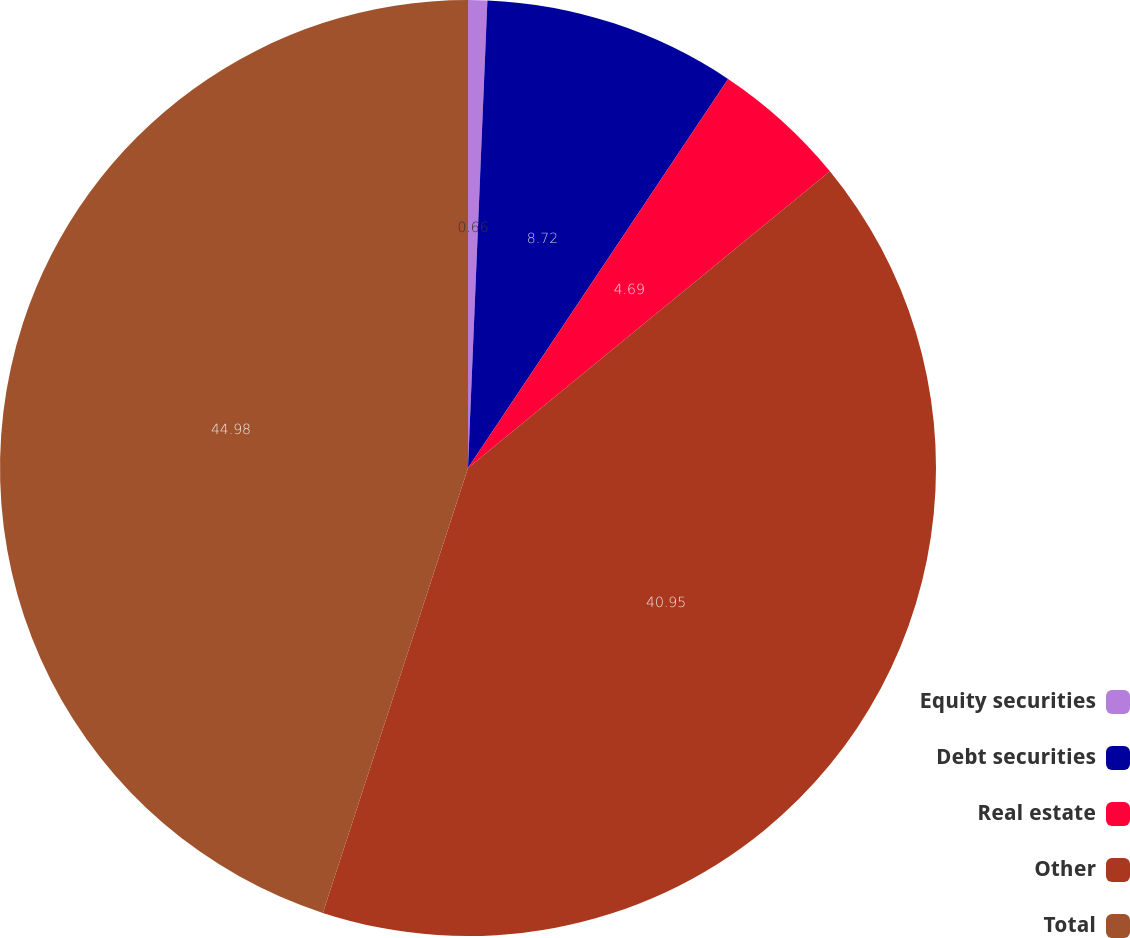Convert chart to OTSL. <chart><loc_0><loc_0><loc_500><loc_500><pie_chart><fcel>Equity securities<fcel>Debt securities<fcel>Real estate<fcel>Other<fcel>Total<nl><fcel>0.66%<fcel>8.72%<fcel>4.69%<fcel>40.95%<fcel>44.98%<nl></chart> 